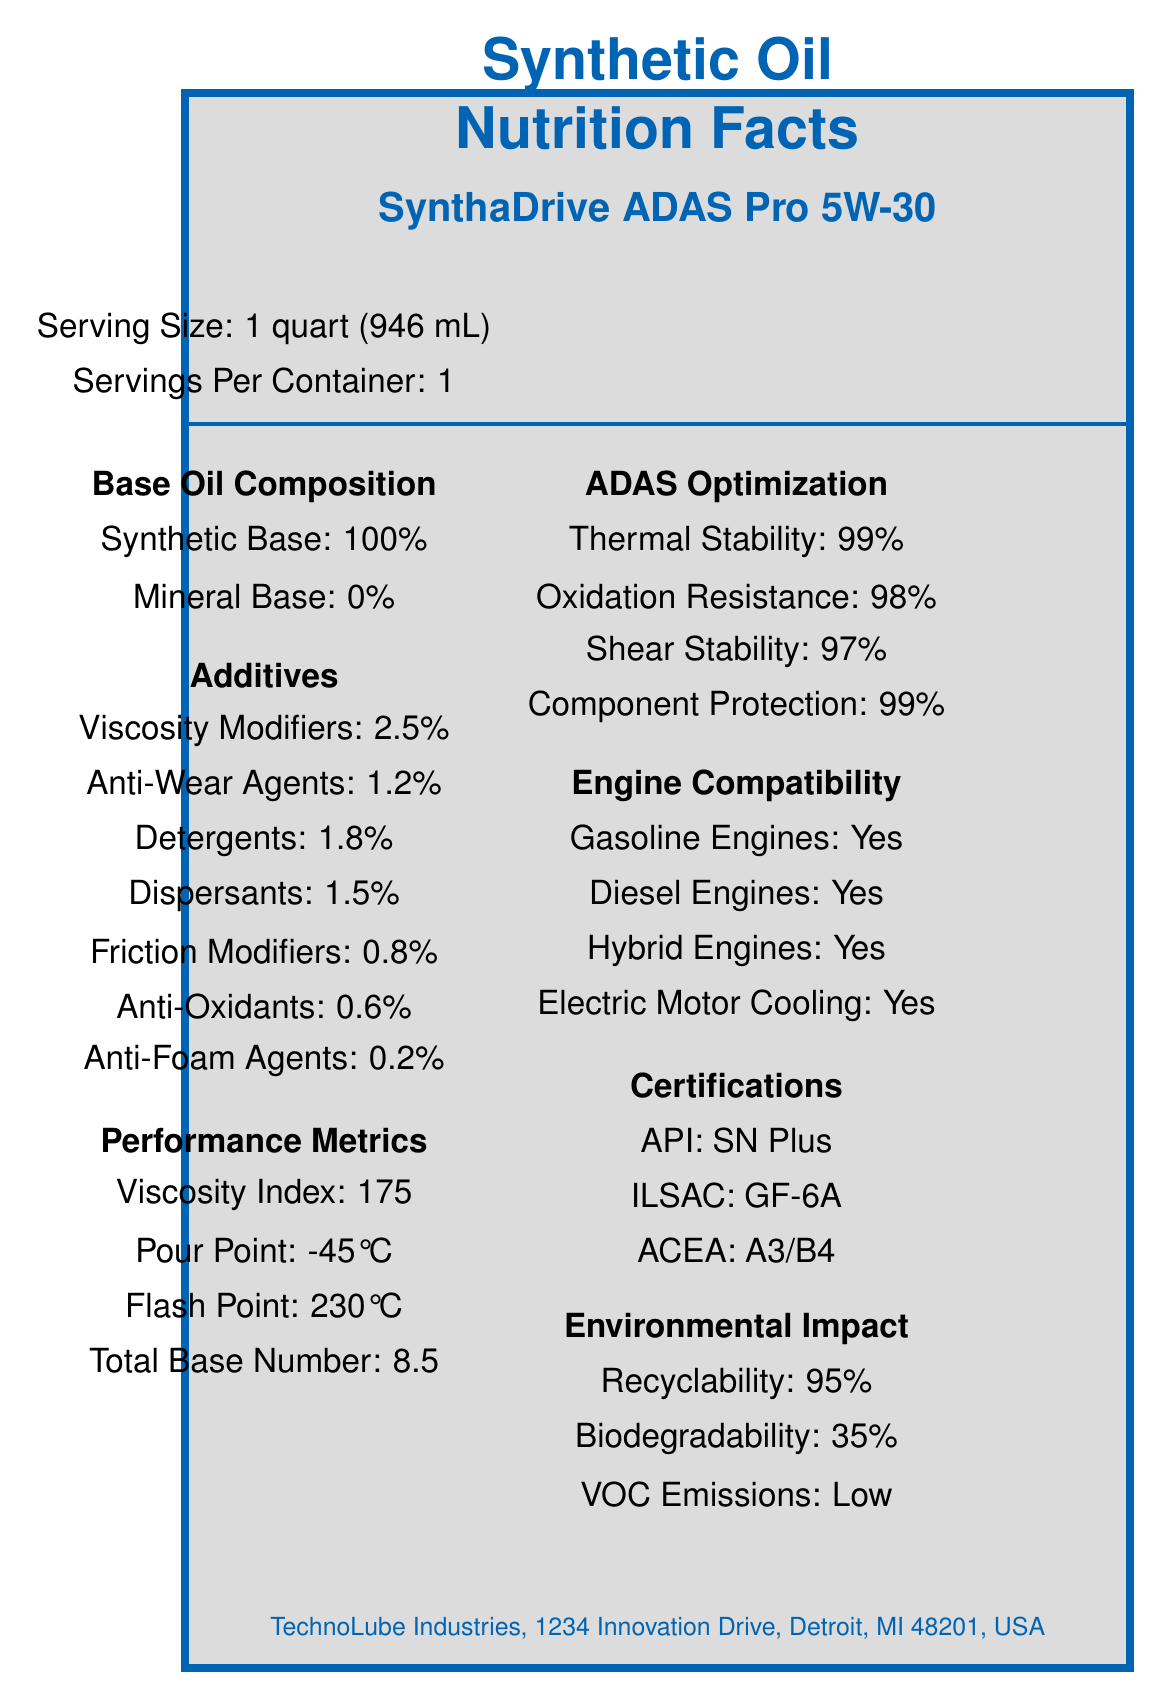what is the product name? The product name can be found at the top of the label under "SynthaDrive ADAS Pro 5W-30".
Answer: SynthaDrive ADAS Pro 5W-30 what is the serving size? This information is stated clearly in the "Serving Size" section at the beginning of the label.
Answer: 1 quart (946 mL) how many servings are there per container? This is mentioned right below the serving size information, indicating that there is only one serving per container.
Answer: 1 what are the primary additives in this synthetic oil? The label lists the primary additives under the "Additives" section, providing specific types and their respective percentages.
Answer: Viscosity Modifiers, Anti-Wear Agents, Detergents, Dispersants, Friction Modifiers, Anti-Oxidants, Anti-Foam Agents what is the viscosity index of the oil? The viscosity index, which indicates the oil's stability across temperature changes, is listed under "Performance Metrics".
Answer: 175 what is the pour point of the oil? The pour point, which shows the lowest temperature at which the oil remains pourable, is also listed under "Performance Metrics".
Answer: -45°C what are the four types of engines this oil is compatible with? The "Compatibility" section lists all four types of engines that this oil can be used with.
Answer: Gasoline Engines, Diesel Engines, Hybrid Engines, Electric Motor Cooling what certifications does this oil hold? The "Certifications" section lists the three certifications the oil has obtained.
Answer: API: SN Plus, ILSAC: GF-6A, ACEA: A3/B4 which of the following is not an additive in the oil? A. Viscosity Modifiers B. Anti-Wear Agents C. Detergents D. Corrosion Inhibitors E. Anti-Oxidants Corrosion inhibitors are not listed in the "Additives" section, while all other options are.
Answer: D. Corrosion Inhibitors what percentage of the base oil is synthetic? Under "Base Oil Composition," it states that the oil is 100% synthetic.
Answer: 100% which performance metric indicates the oil's resistance to flow at low temperatures? A. Viscosity Index B. Pour Point C. Flash Point D. Total Base Number The pour point indicates how well the oil performs at low temperatures.
Answer: B. Pour Point is this oil suitable for brake fluids? The "Not Suitable For" section specifies that this oil is not suitable for brake fluids.
Answer: No summarize the main features of SynthaDrive ADAS Pro 5W-30. This summary captures the core aspects of the product, including its purpose, composition, performance metrics, compatibility, certifications, and environmental considerations.
Answer: SynthaDrive ADAS Pro 5W-30 is a high-performance synthetic oil optimized for advanced driver assistance systems (ADAS). It contains various additives for enhanced performance, has excellent thermal and oxidation stability, and is compatible with multiple types of engines. It holds several industry certifications and has a low environmental impact. what is the recommended change interval for this oil? The "Recommended change interval" section of the label states this clearly.
Answer: 15,000 miles or 1 year what is the recyclability percentage of this oil? The "Environmental Impact" section lists the recyclability percentage of the oil.
Answer: 95% what thermal stability percentage is indicated for ADAS optimization? Under "ADAS Optimization," the thermal stability percentage is given as 99%.
Answer: 99% how should the oil be disposed of? The "Disposal Instructions" section advises recycling at authorized collection points.
Answer: Recycle at authorized collection points how long is the shelf life of this oil? The shelf life of 5 years is mentioned towards the end of the label.
Answer: 5 years what is the contact address for the manufacturer of SynthaDrive ADAS Pro 5W-30? This information is provided in the footer of the label.
Answer: TechnoLube Industries, 1234 Innovation Drive, Detroit, MI 48201, USA what is the biodegradability percentage of this oil? The "Environmental Impact" section includes the biodegradability percentage of the oil.
Answer: 35% does this oil provide protection to ADAS components like radar sensors and lidar systems? The label indicates "Suitable for ADAS Components" including radar sensors and lidar systems.
Answer: Yes where should this oil be stored? A. In a hot environment B. In a humid place C. In a cool, dry place away from direct sunlight D. In an open area The "Storage Instructions" section specifies that the oil should be stored in a cool, dry place away from direct sunlight.
Answer: C. In a cool, dry place away from direct sunlight is there any information about the price of the oil on the label? The label does not provide any details related to the price of SynthaDrive ADAS Pro 5W-30.
Answer: Not enough information 